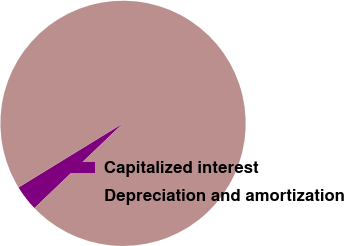Convert chart. <chart><loc_0><loc_0><loc_500><loc_500><pie_chart><fcel>Capitalized interest<fcel>Depreciation and amortization<nl><fcel>3.39%<fcel>96.61%<nl></chart> 